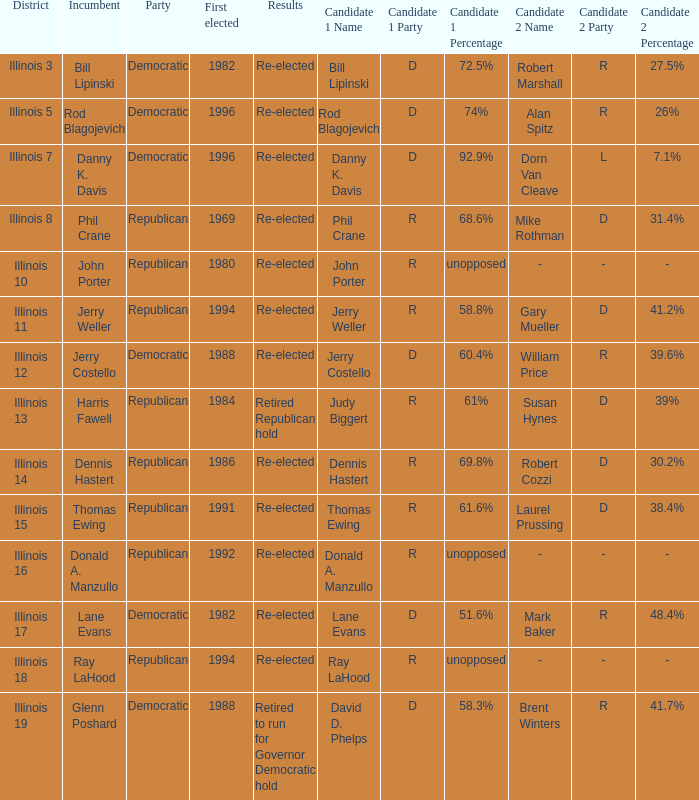What was the result in Illinois 7? Re-elected. 